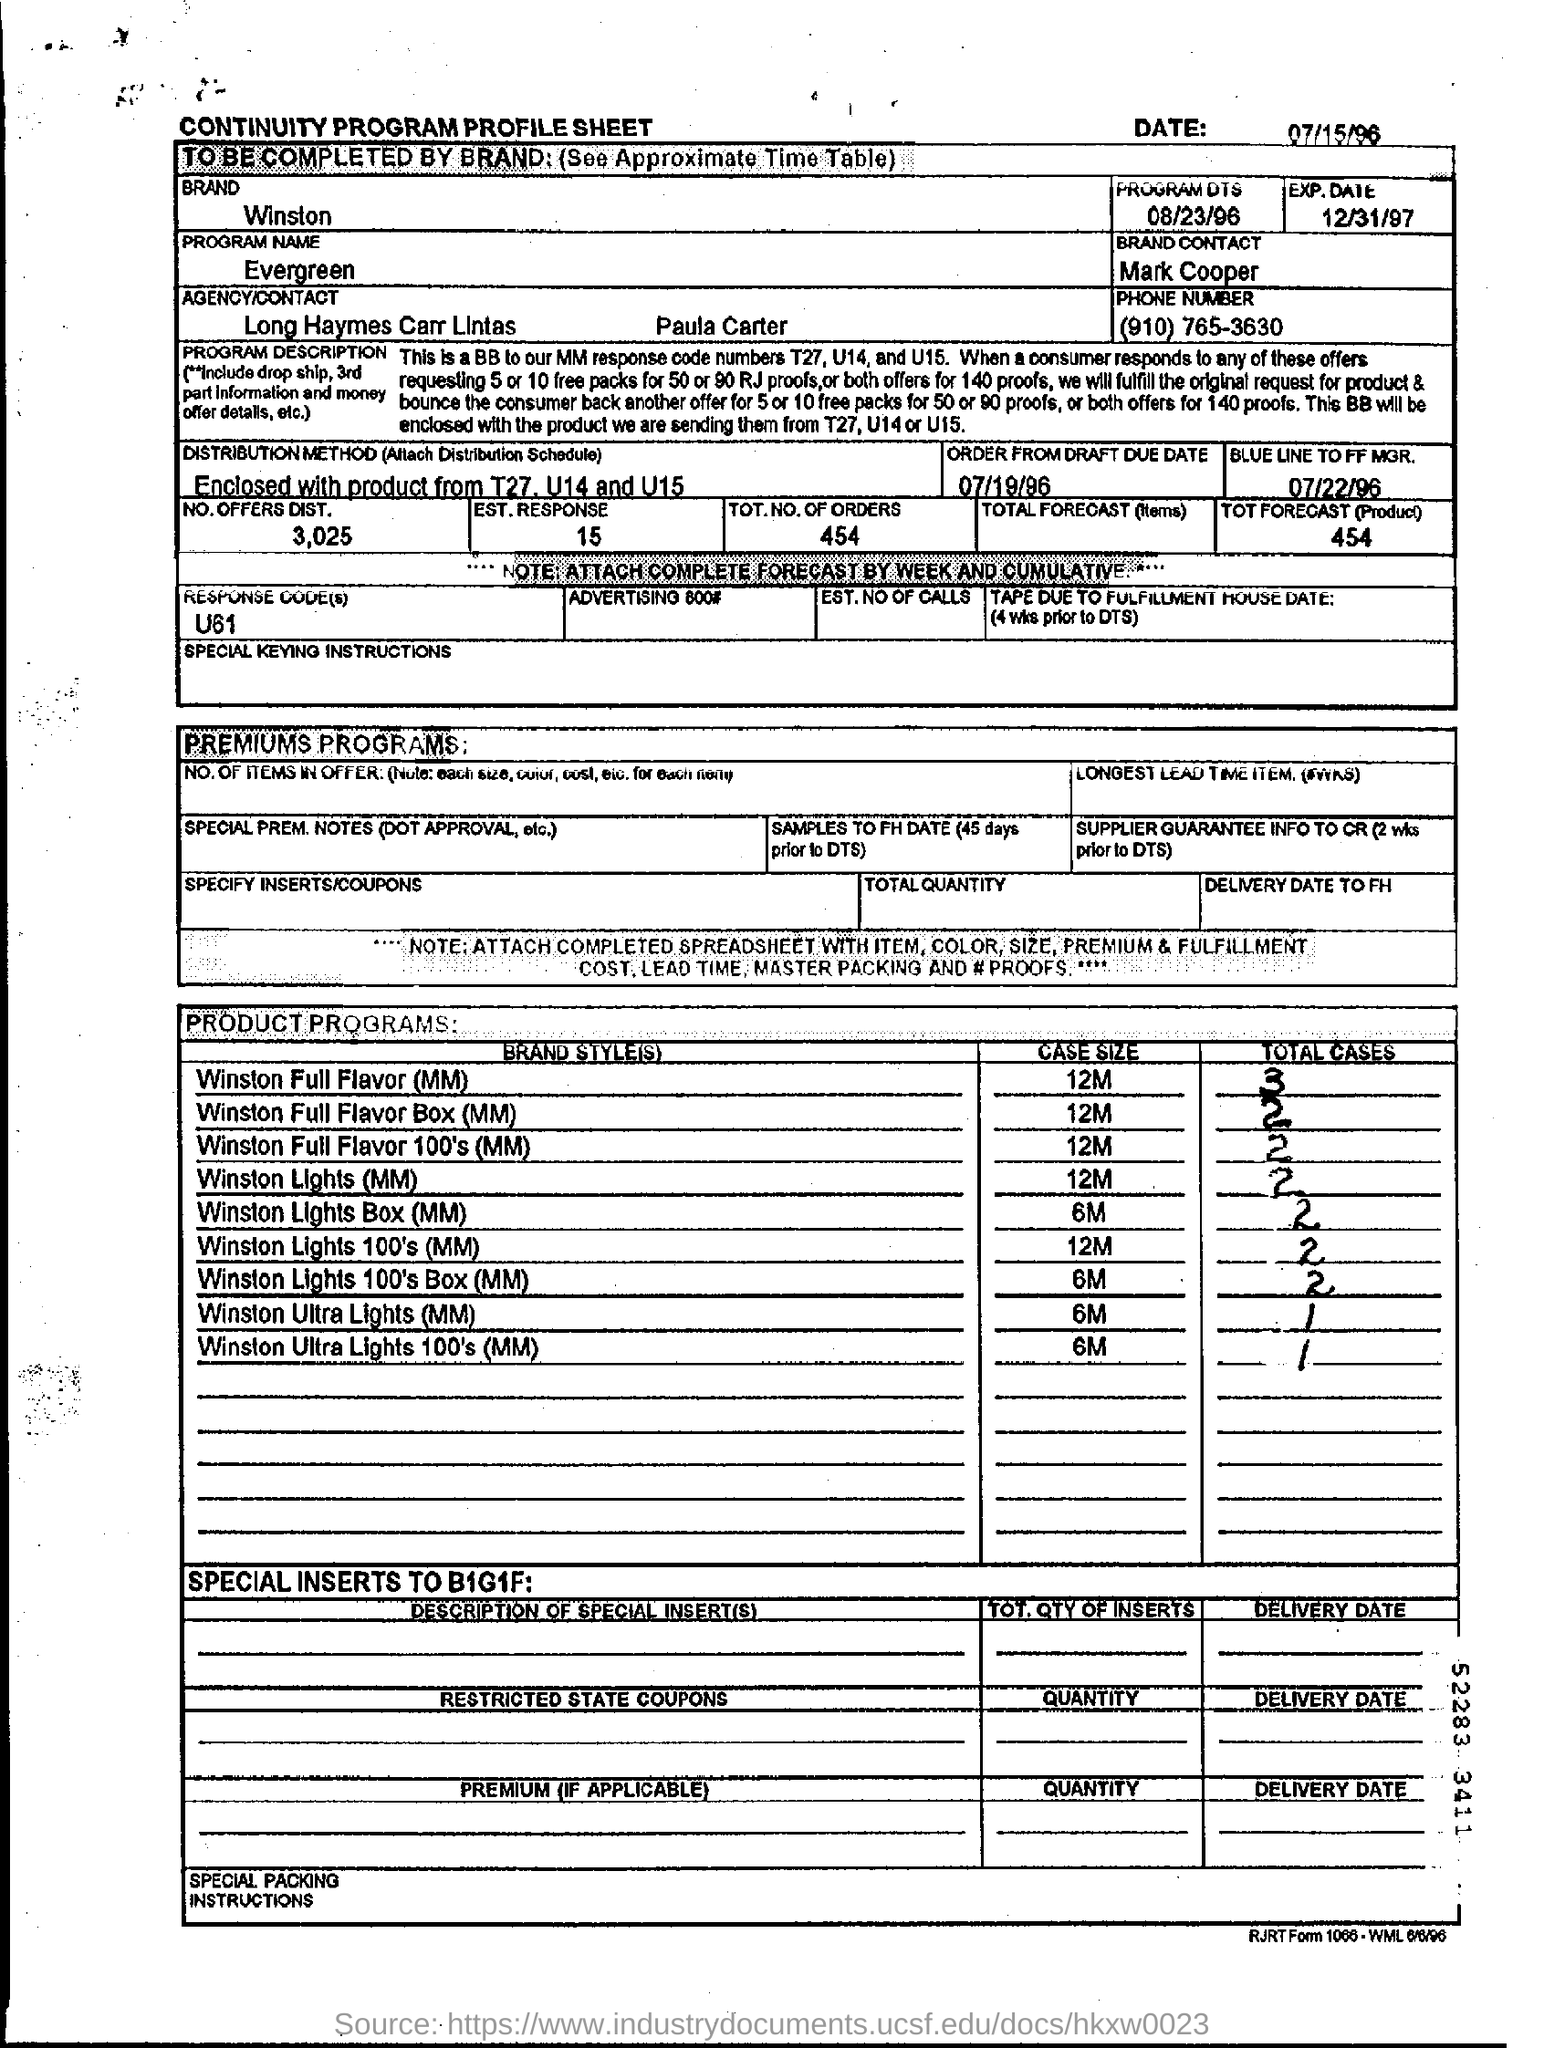What is the Program Name ?
Provide a short and direct response. Evergreen. Which response code assigned ?
Ensure brevity in your answer.  U61. What is the case size of Winston Lights (MM) ?
Keep it short and to the point. 12M. What are the total number of orders ?
Your response must be concise. 454. 